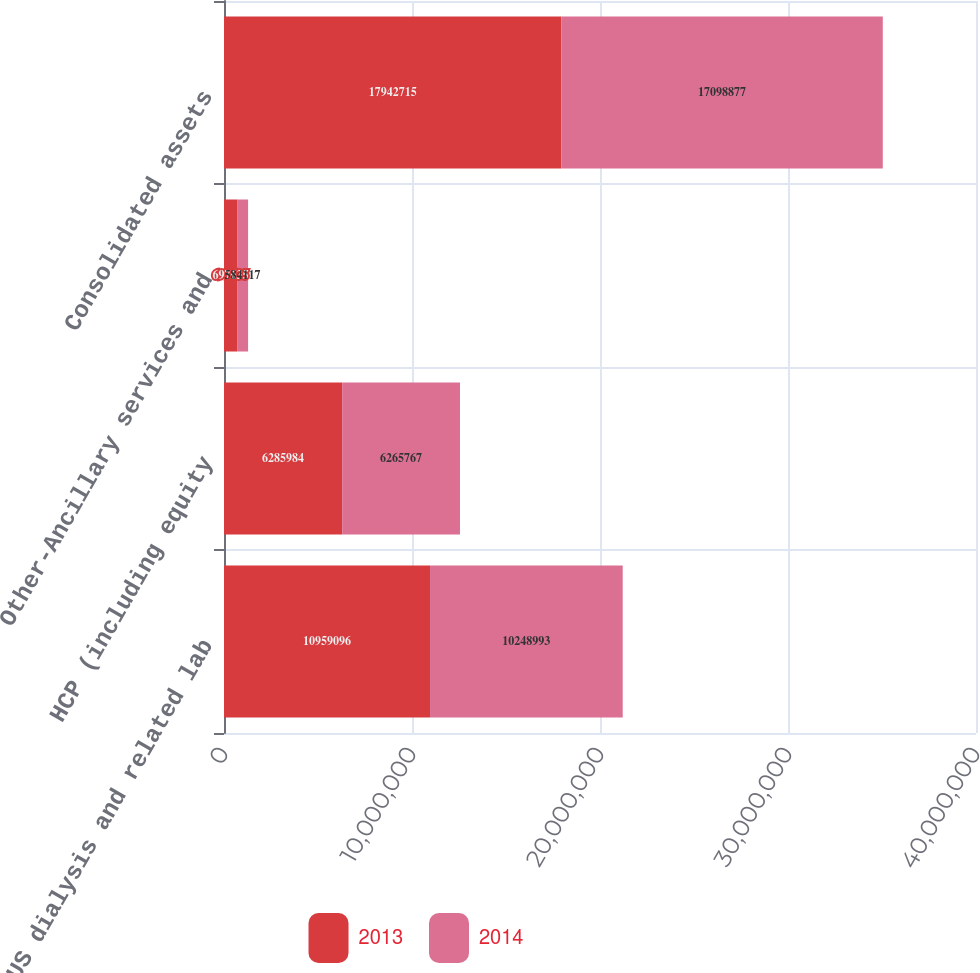Convert chart to OTSL. <chart><loc_0><loc_0><loc_500><loc_500><stacked_bar_chart><ecel><fcel>US dialysis and related lab<fcel>HCP (including equity<fcel>Other-Ancillary services and<fcel>Consolidated assets<nl><fcel>2013<fcel>1.09591e+07<fcel>6.28598e+06<fcel>697635<fcel>1.79427e+07<nl><fcel>2014<fcel>1.0249e+07<fcel>6.26577e+06<fcel>584117<fcel>1.70989e+07<nl></chart> 